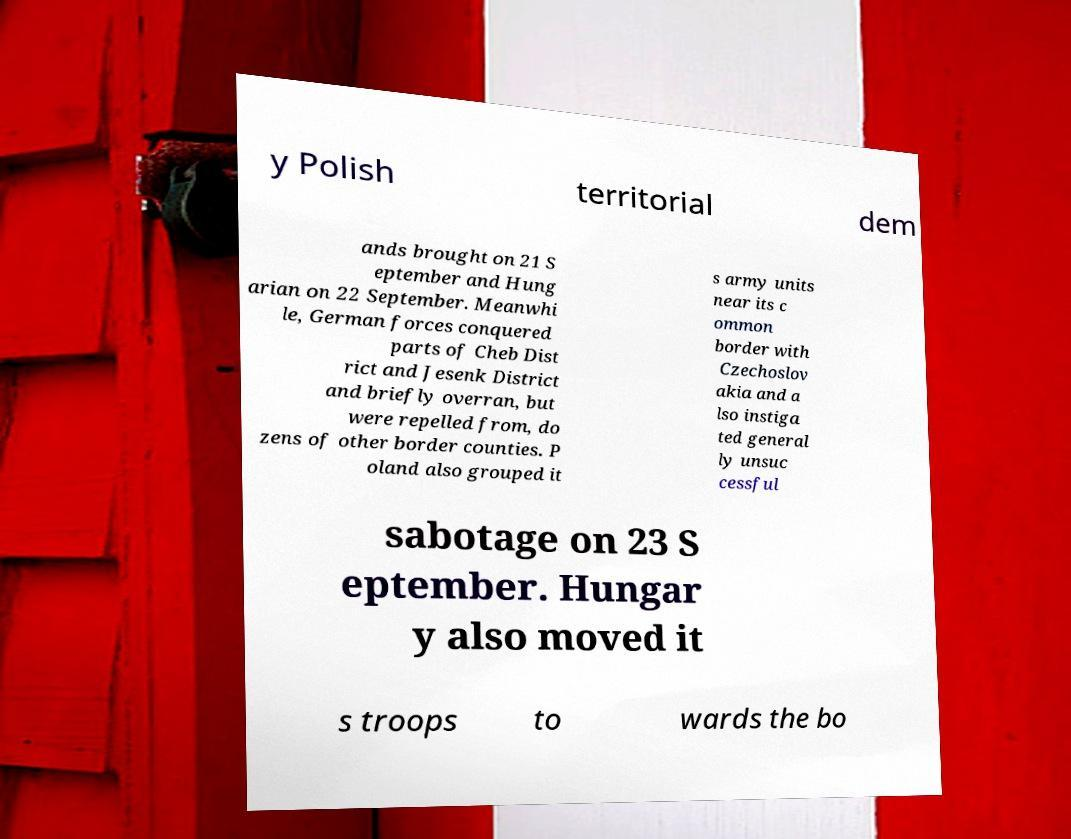Can you accurately transcribe the text from the provided image for me? y Polish territorial dem ands brought on 21 S eptember and Hung arian on 22 September. Meanwhi le, German forces conquered parts of Cheb Dist rict and Jesenk District and briefly overran, but were repelled from, do zens of other border counties. P oland also grouped it s army units near its c ommon border with Czechoslov akia and a lso instiga ted general ly unsuc cessful sabotage on 23 S eptember. Hungar y also moved it s troops to wards the bo 